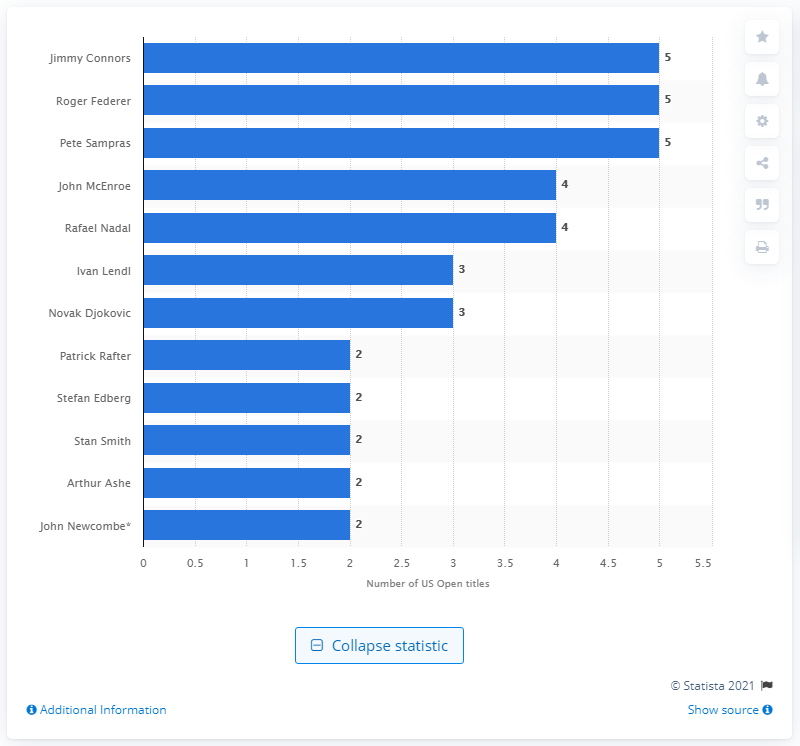Indicate a few pertinent items in this graphic. Roger Federer has won the U.S. Open five times, making him the player with the most victories in this prestigious tennis tournament. 